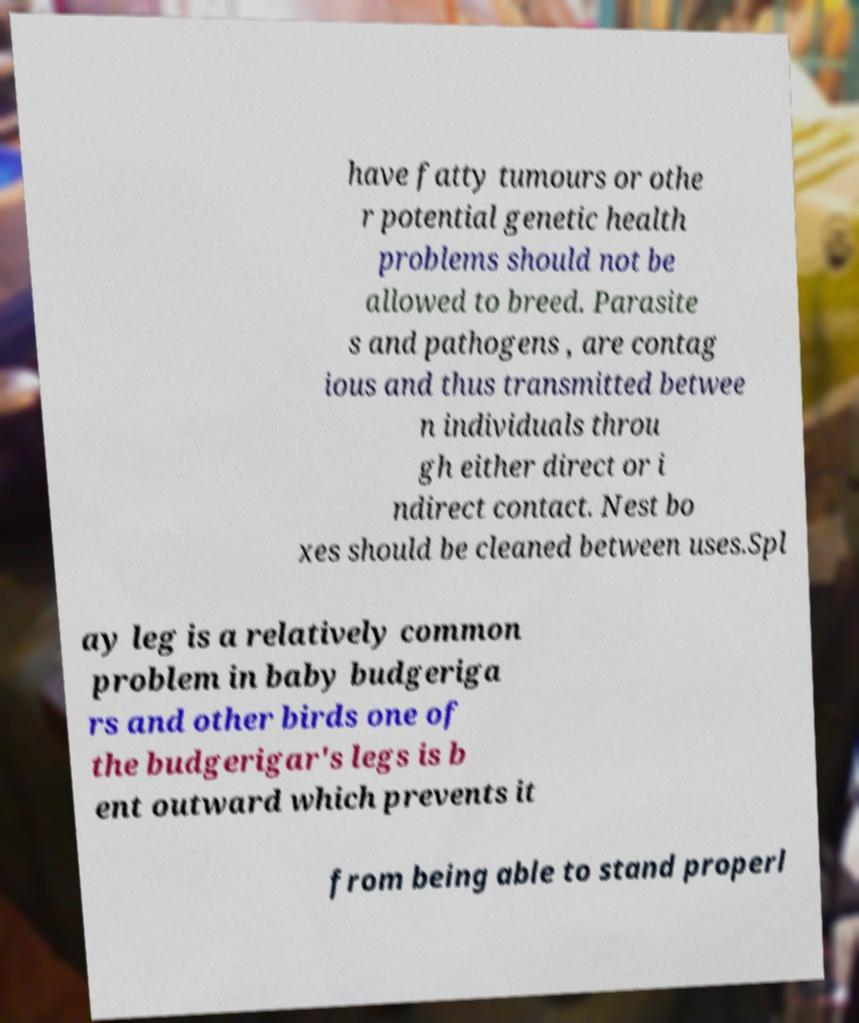Please read and relay the text visible in this image. What does it say? have fatty tumours or othe r potential genetic health problems should not be allowed to breed. Parasite s and pathogens , are contag ious and thus transmitted betwee n individuals throu gh either direct or i ndirect contact. Nest bo xes should be cleaned between uses.Spl ay leg is a relatively common problem in baby budgeriga rs and other birds one of the budgerigar's legs is b ent outward which prevents it from being able to stand properl 